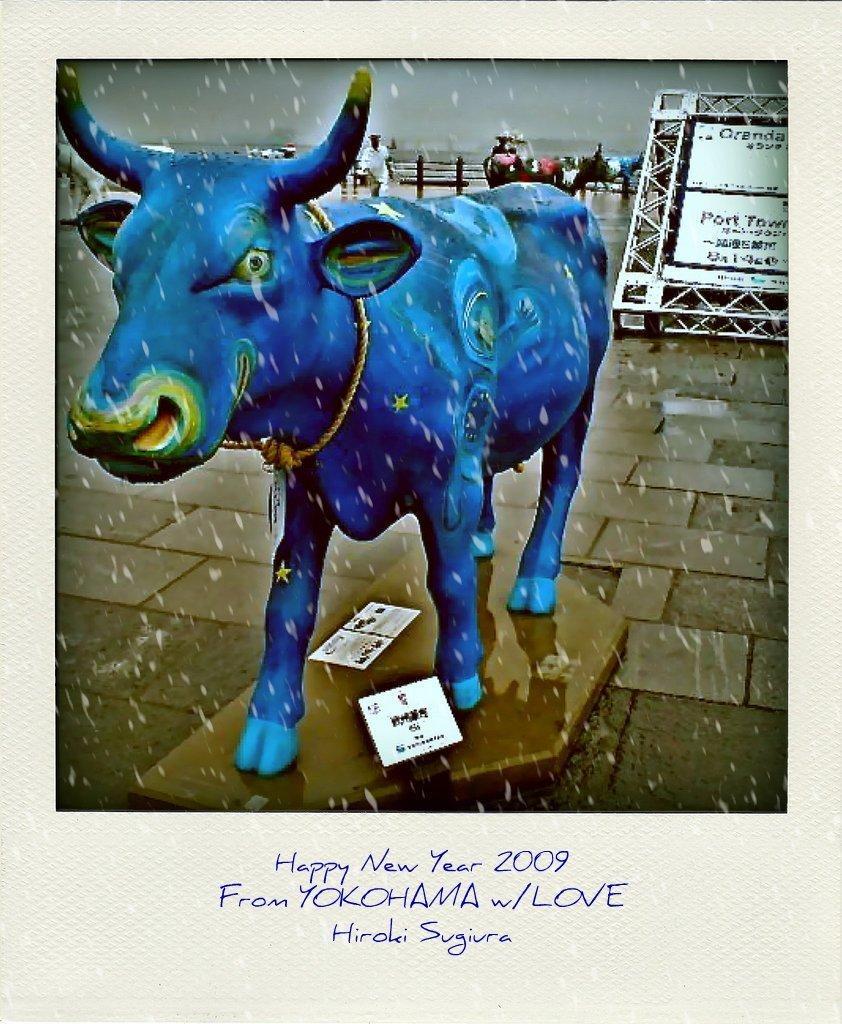Could you give a brief overview of what you see in this image? In the center of the image we can see one poster. On the poster, we can see one stone. On the stone, we can see banners and one statue, which is in blue color. And we can see one rope around the statue's neck. In the background, we can see the sky, clouds, animals, one banner, few people are standing, fence and a few other objects. And we can see some white color dots on the image. On the banner, we can see some text. At the bottom of the image, we can see some text. 